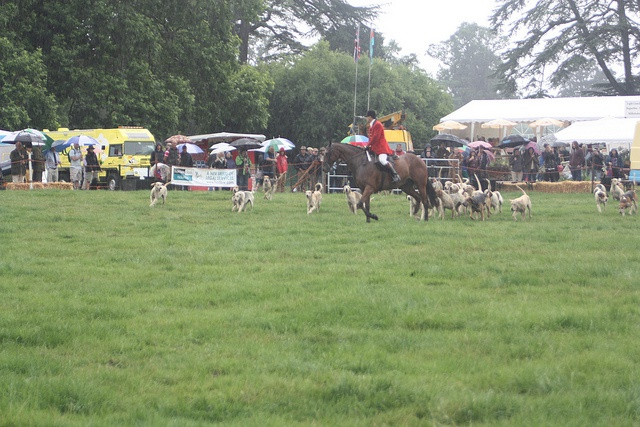Describe the objects in this image and their specific colors. I can see people in black, gray, darkgray, and lightgray tones, truck in black, khaki, ivory, gray, and darkgray tones, horse in black, gray, and darkgray tones, dog in black, olive, gray, and darkgray tones, and umbrella in black, gray, darkgray, and lightgray tones in this image. 